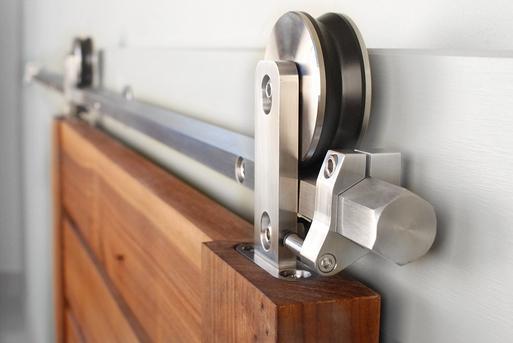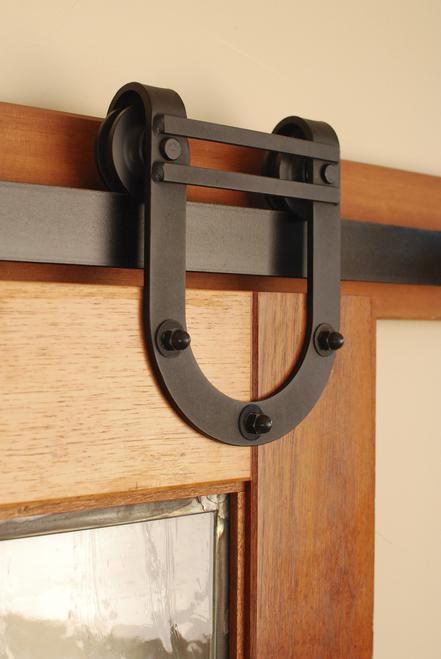The first image is the image on the left, the second image is the image on the right. For the images displayed, is the sentence "There are three doors." factually correct? Answer yes or no. No. 